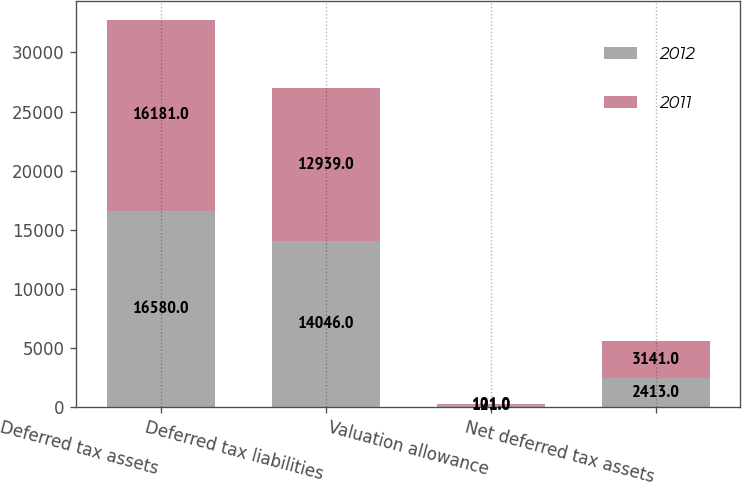Convert chart. <chart><loc_0><loc_0><loc_500><loc_500><stacked_bar_chart><ecel><fcel>Deferred tax assets<fcel>Deferred tax liabilities<fcel>Valuation allowance<fcel>Net deferred tax assets<nl><fcel>2012<fcel>16580<fcel>14046<fcel>121<fcel>2413<nl><fcel>2011<fcel>16181<fcel>12939<fcel>101<fcel>3141<nl></chart> 